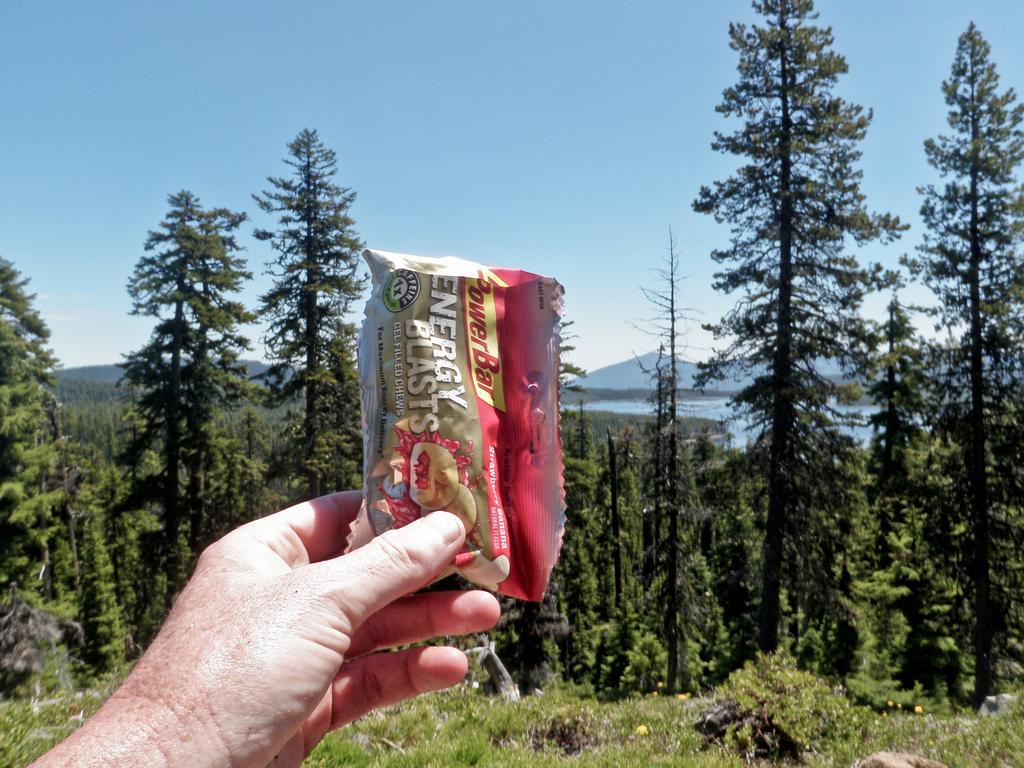Could you give a brief overview of what you see in this image? In this image I can see the person holding the packet which is in red and green color. And I can see the name energy blasts is written on it. In the background there are many trees, mountains and the blue sky. 